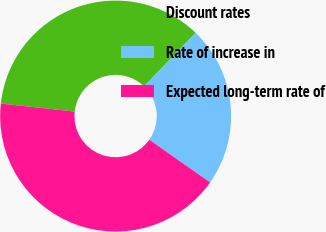Convert chart. <chart><loc_0><loc_0><loc_500><loc_500><pie_chart><fcel>Discount rates<fcel>Rate of increase in<fcel>Expected long-term rate of<nl><fcel>35.45%<fcel>22.56%<fcel>41.99%<nl></chart> 